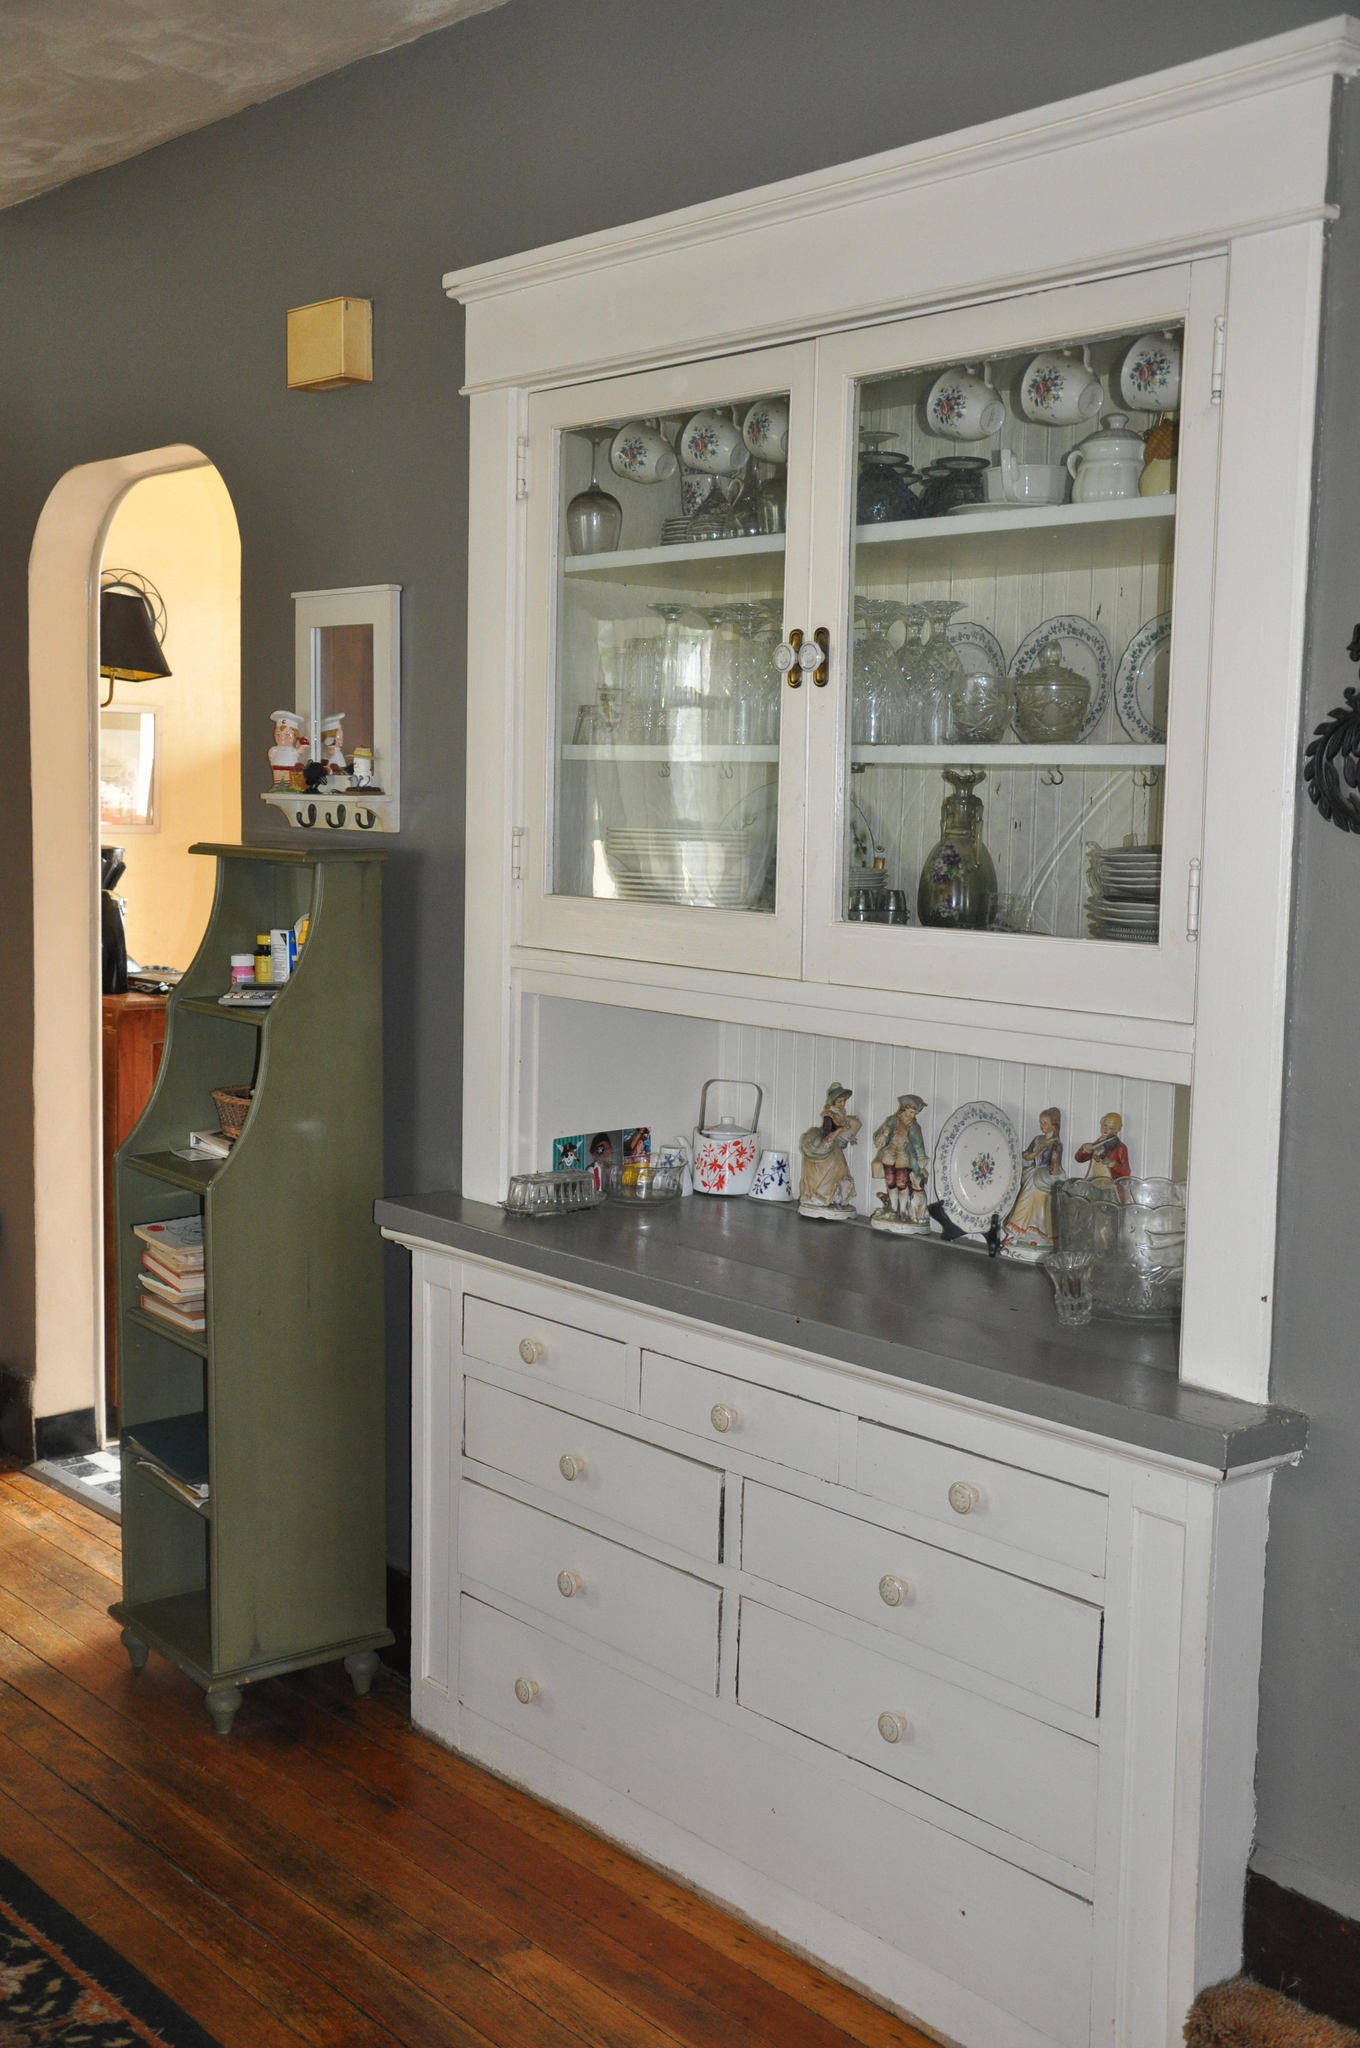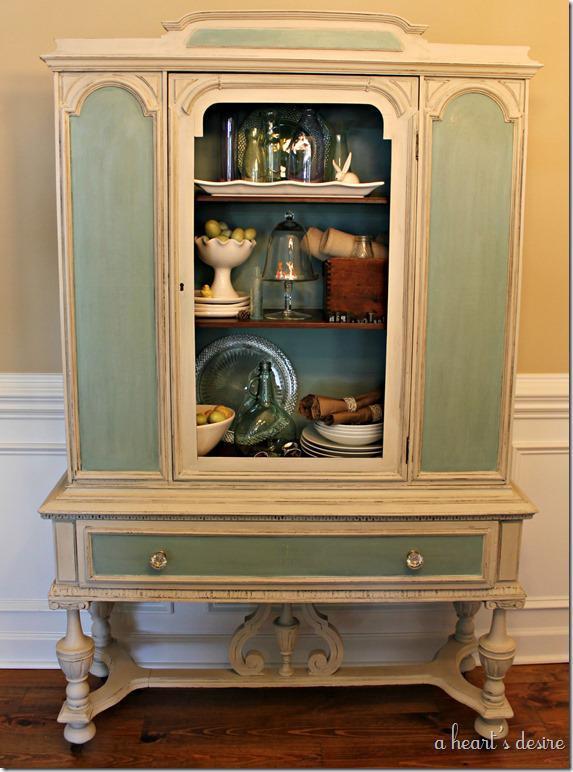The first image is the image on the left, the second image is the image on the right. Examine the images to the left and right. Is the description "One of the cabinets is empty inside." accurate? Answer yes or no. No. The first image is the image on the left, the second image is the image on the right. Considering the images on both sides, is "the right pic furniture piece has 3 or more glass panels" valid? Answer yes or no. No. 